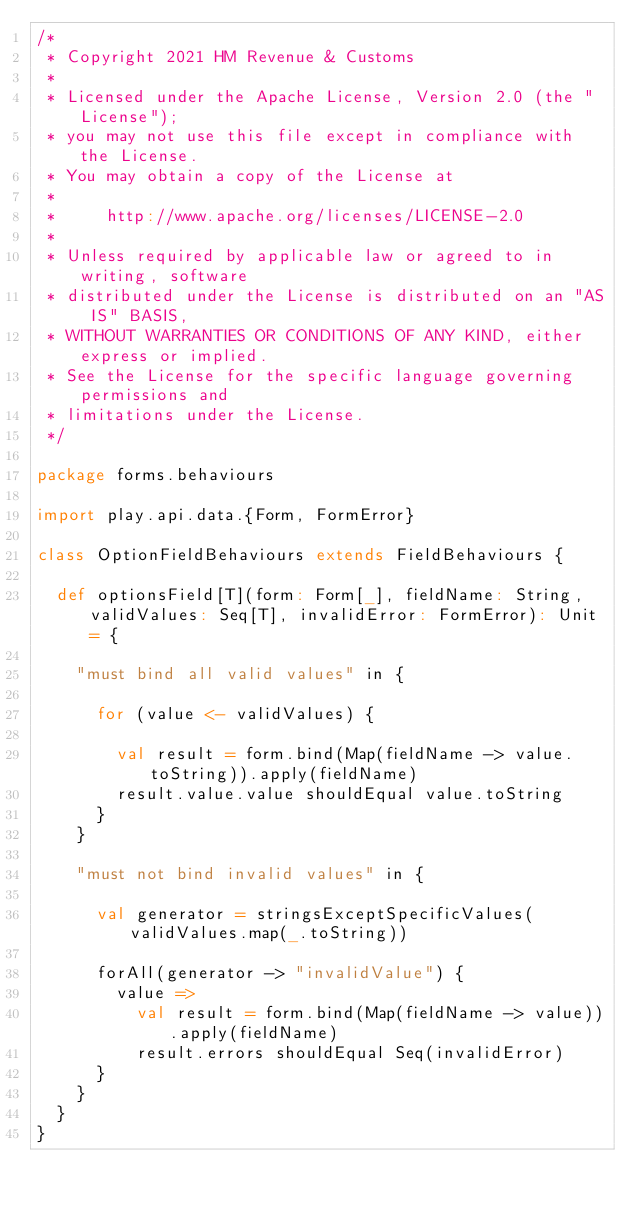Convert code to text. <code><loc_0><loc_0><loc_500><loc_500><_Scala_>/*
 * Copyright 2021 HM Revenue & Customs
 *
 * Licensed under the Apache License, Version 2.0 (the "License");
 * you may not use this file except in compliance with the License.
 * You may obtain a copy of the License at
 *
 *     http://www.apache.org/licenses/LICENSE-2.0
 *
 * Unless required by applicable law or agreed to in writing, software
 * distributed under the License is distributed on an "AS IS" BASIS,
 * WITHOUT WARRANTIES OR CONDITIONS OF ANY KIND, either express or implied.
 * See the License for the specific language governing permissions and
 * limitations under the License.
 */

package forms.behaviours

import play.api.data.{Form, FormError}

class OptionFieldBehaviours extends FieldBehaviours {

  def optionsField[T](form: Form[_], fieldName: String, validValues: Seq[T], invalidError: FormError): Unit = {

    "must bind all valid values" in {

      for (value <- validValues) {

        val result = form.bind(Map(fieldName -> value.toString)).apply(fieldName)
        result.value.value shouldEqual value.toString
      }
    }

    "must not bind invalid values" in {

      val generator = stringsExceptSpecificValues(validValues.map(_.toString))

      forAll(generator -> "invalidValue") {
        value =>
          val result = form.bind(Map(fieldName -> value)).apply(fieldName)
          result.errors shouldEqual Seq(invalidError)
      }
    }
  }
}
</code> 